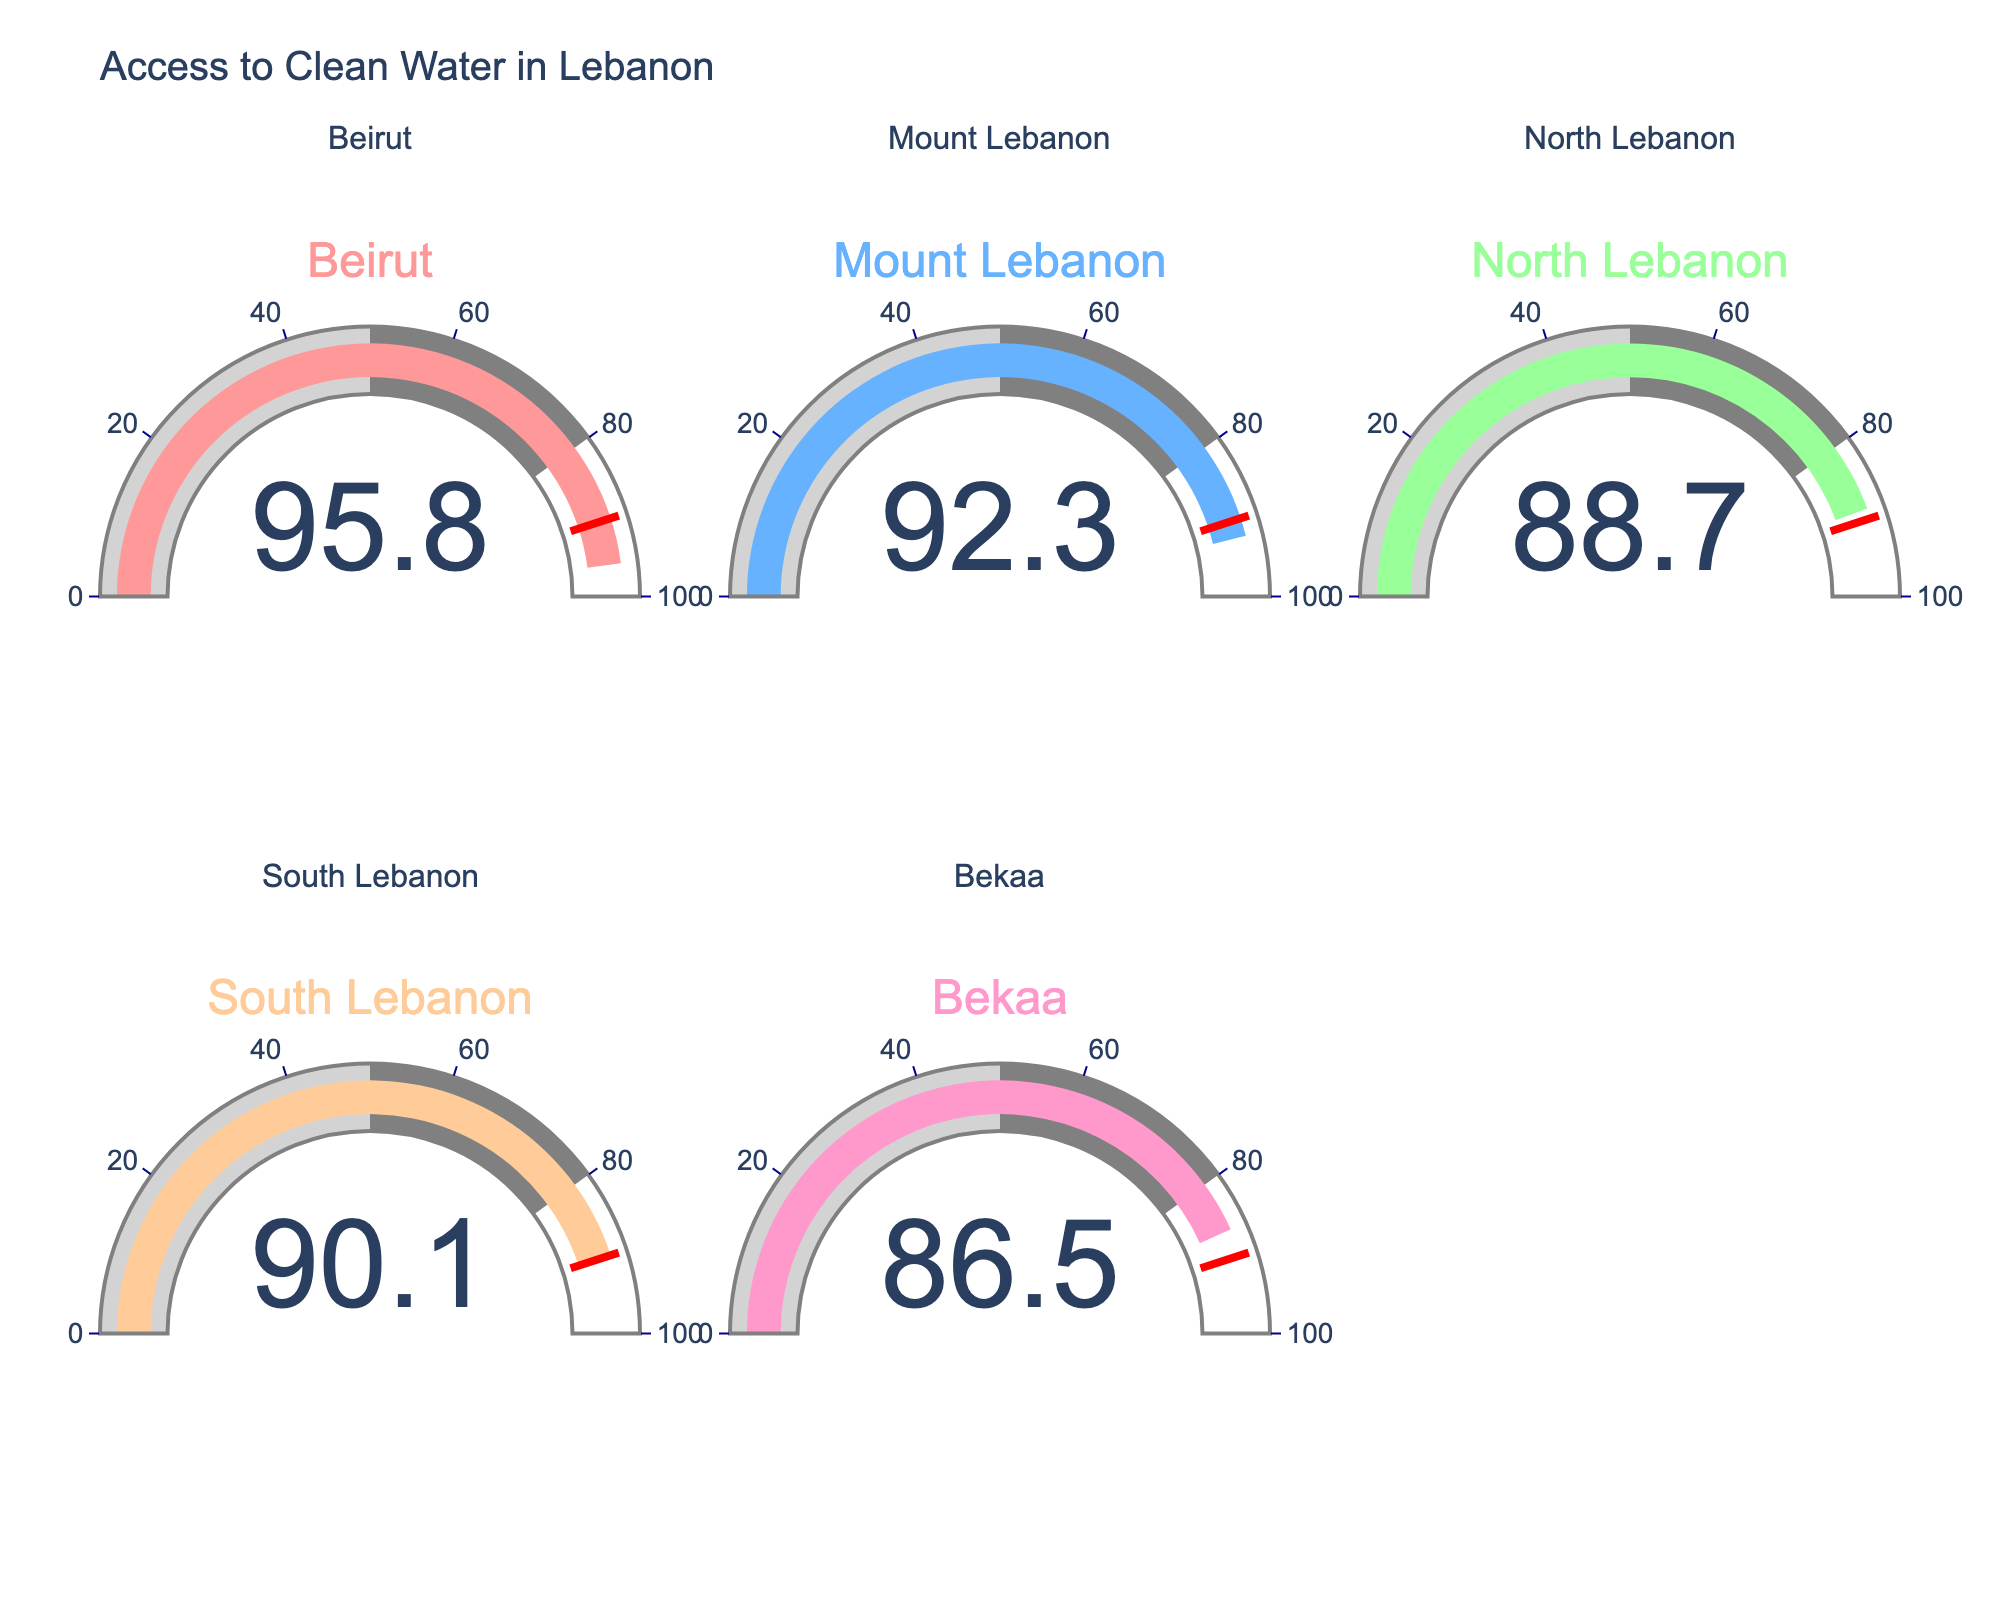what percentage of Beirut's population has access to clean water? The gauge chart for Beirut shows a single number which represents the percentage. To find this, look at the value on Beirut's gauge.
Answer: 95.8 Which region has the lowest access to clean water? Compare the values shown on each gauge for all regions and determine which one is the smallest.
Answer: Bekaa What is the average percentage of populations with access to clean water across all regions? Sum the values from all gauges and then divide by the number of regions: (95.8 + 92.3 + 88.7 + 90.1 + 86.5) / 5 = 453.4 / 5 = 90.68
Answer: 90.68 Is the percentage of clean water access in Mount Lebanon higher or lower than in North Lebanon? Compare the values on the gauge charts for Mount Lebanon and North Lebanon. Mount Lebanon is 92.3, and North Lebanon is 88.7, so Mount Lebanon is higher.
Answer: Higher What is the difference in clean water access percentages between the highest and lowest regions? Find the highest value (Beirut, 95.8) and the lowest value (Bekaa, 86.5) and subtract them: 95.8 - 86.5 = 9.3
Answer: 9.3 Which region's clean water access is closest to the 90% threshold? Check each gauge to see how close the values are to 90%. South Lebanon has 90.1 which is closest to 90%.
Answer: South Lebanon What percentage of populations in Bekaa does not have access to clean water? Subtract the percentage of clean water access in Bekaa from 100: 100 - 86.5 = 13.5
Answer: 13.5 How many regions have a clean water access percentage above the 90% threshold? Count the number of gauges with values above 90%. Beirut, Mount Lebanon, and South Lebanon have values above 90%.
Answer: 3 